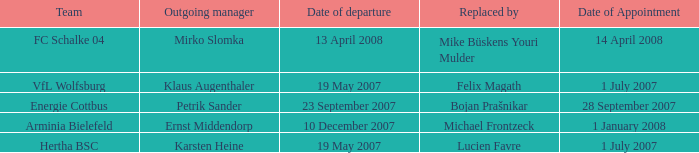When was the appointment date for VFL Wolfsburg? 1 July 2007. 